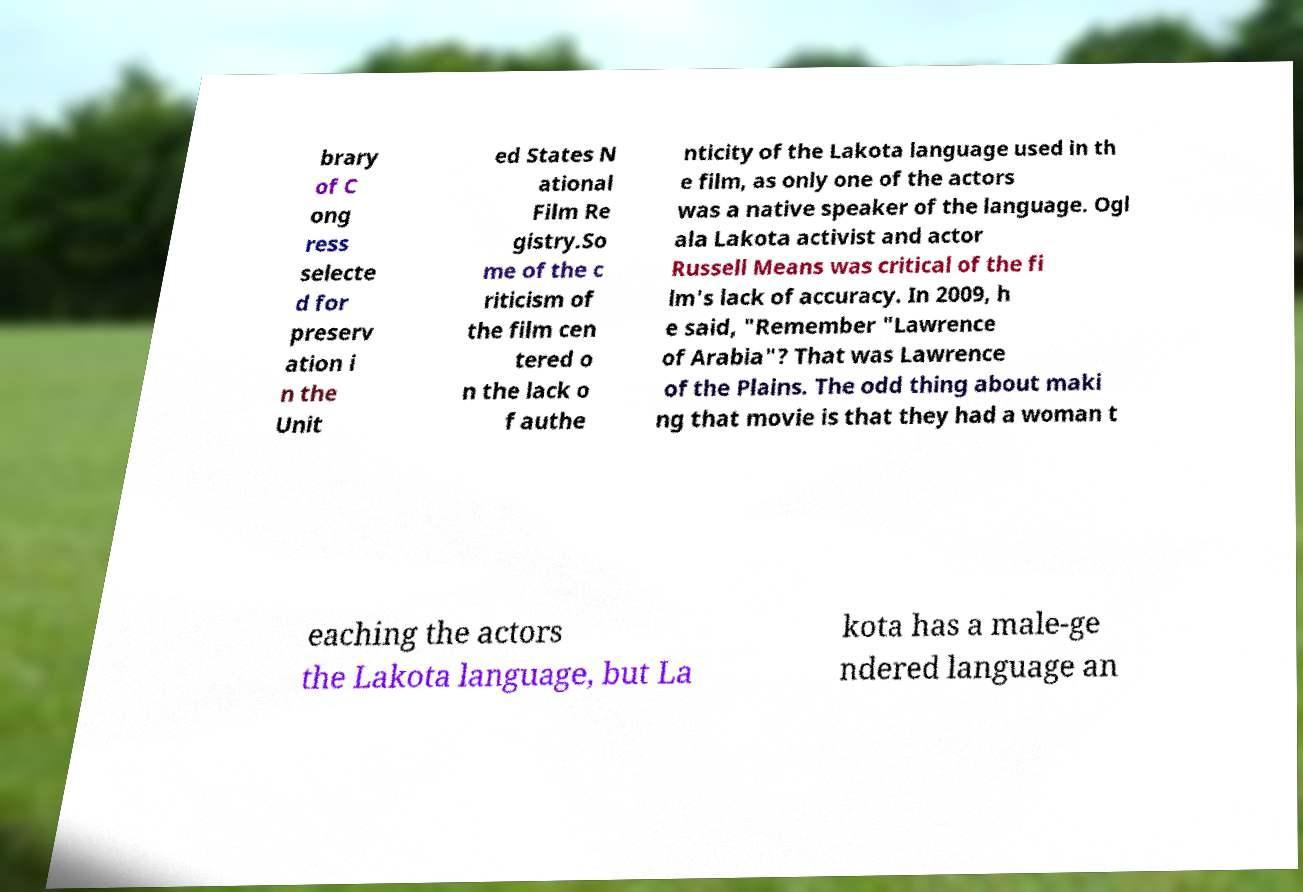Could you extract and type out the text from this image? brary of C ong ress selecte d for preserv ation i n the Unit ed States N ational Film Re gistry.So me of the c riticism of the film cen tered o n the lack o f authe nticity of the Lakota language used in th e film, as only one of the actors was a native speaker of the language. Ogl ala Lakota activist and actor Russell Means was critical of the fi lm's lack of accuracy. In 2009, h e said, "Remember "Lawrence of Arabia"? That was Lawrence of the Plains. The odd thing about maki ng that movie is that they had a woman t eaching the actors the Lakota language, but La kota has a male-ge ndered language an 